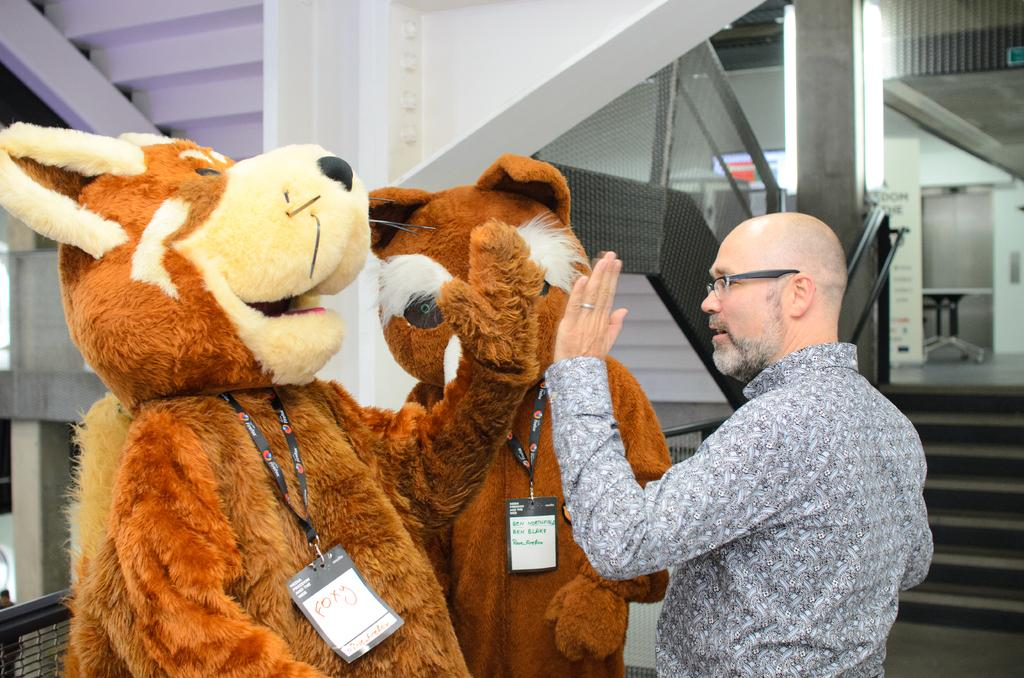How many people are in the image? There are three persons standing in the image. What are the two persons wearing? Two of the persons are wearing fancy dresses. What can be seen in the background of the image? There are staircases, iron grills, a table, and a light in the background of the image. What type of fairies can be seen flying around the persons in the image? There are no fairies present in the image; it only features three persons standing and various background elements. 